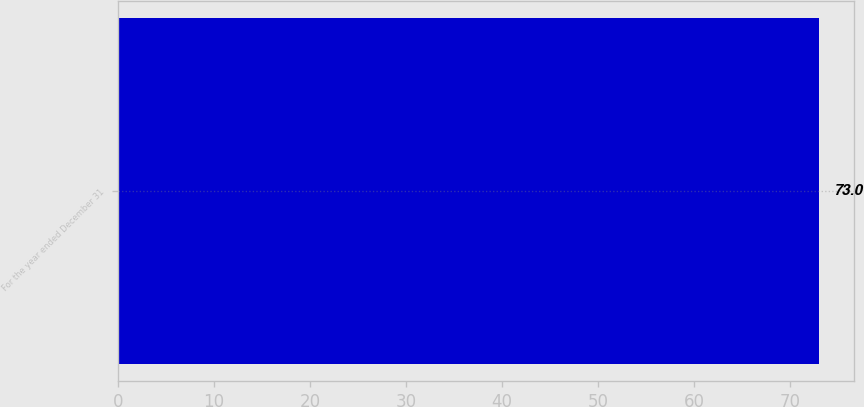Convert chart to OTSL. <chart><loc_0><loc_0><loc_500><loc_500><bar_chart><fcel>For the year ended December 31<nl><fcel>73<nl></chart> 